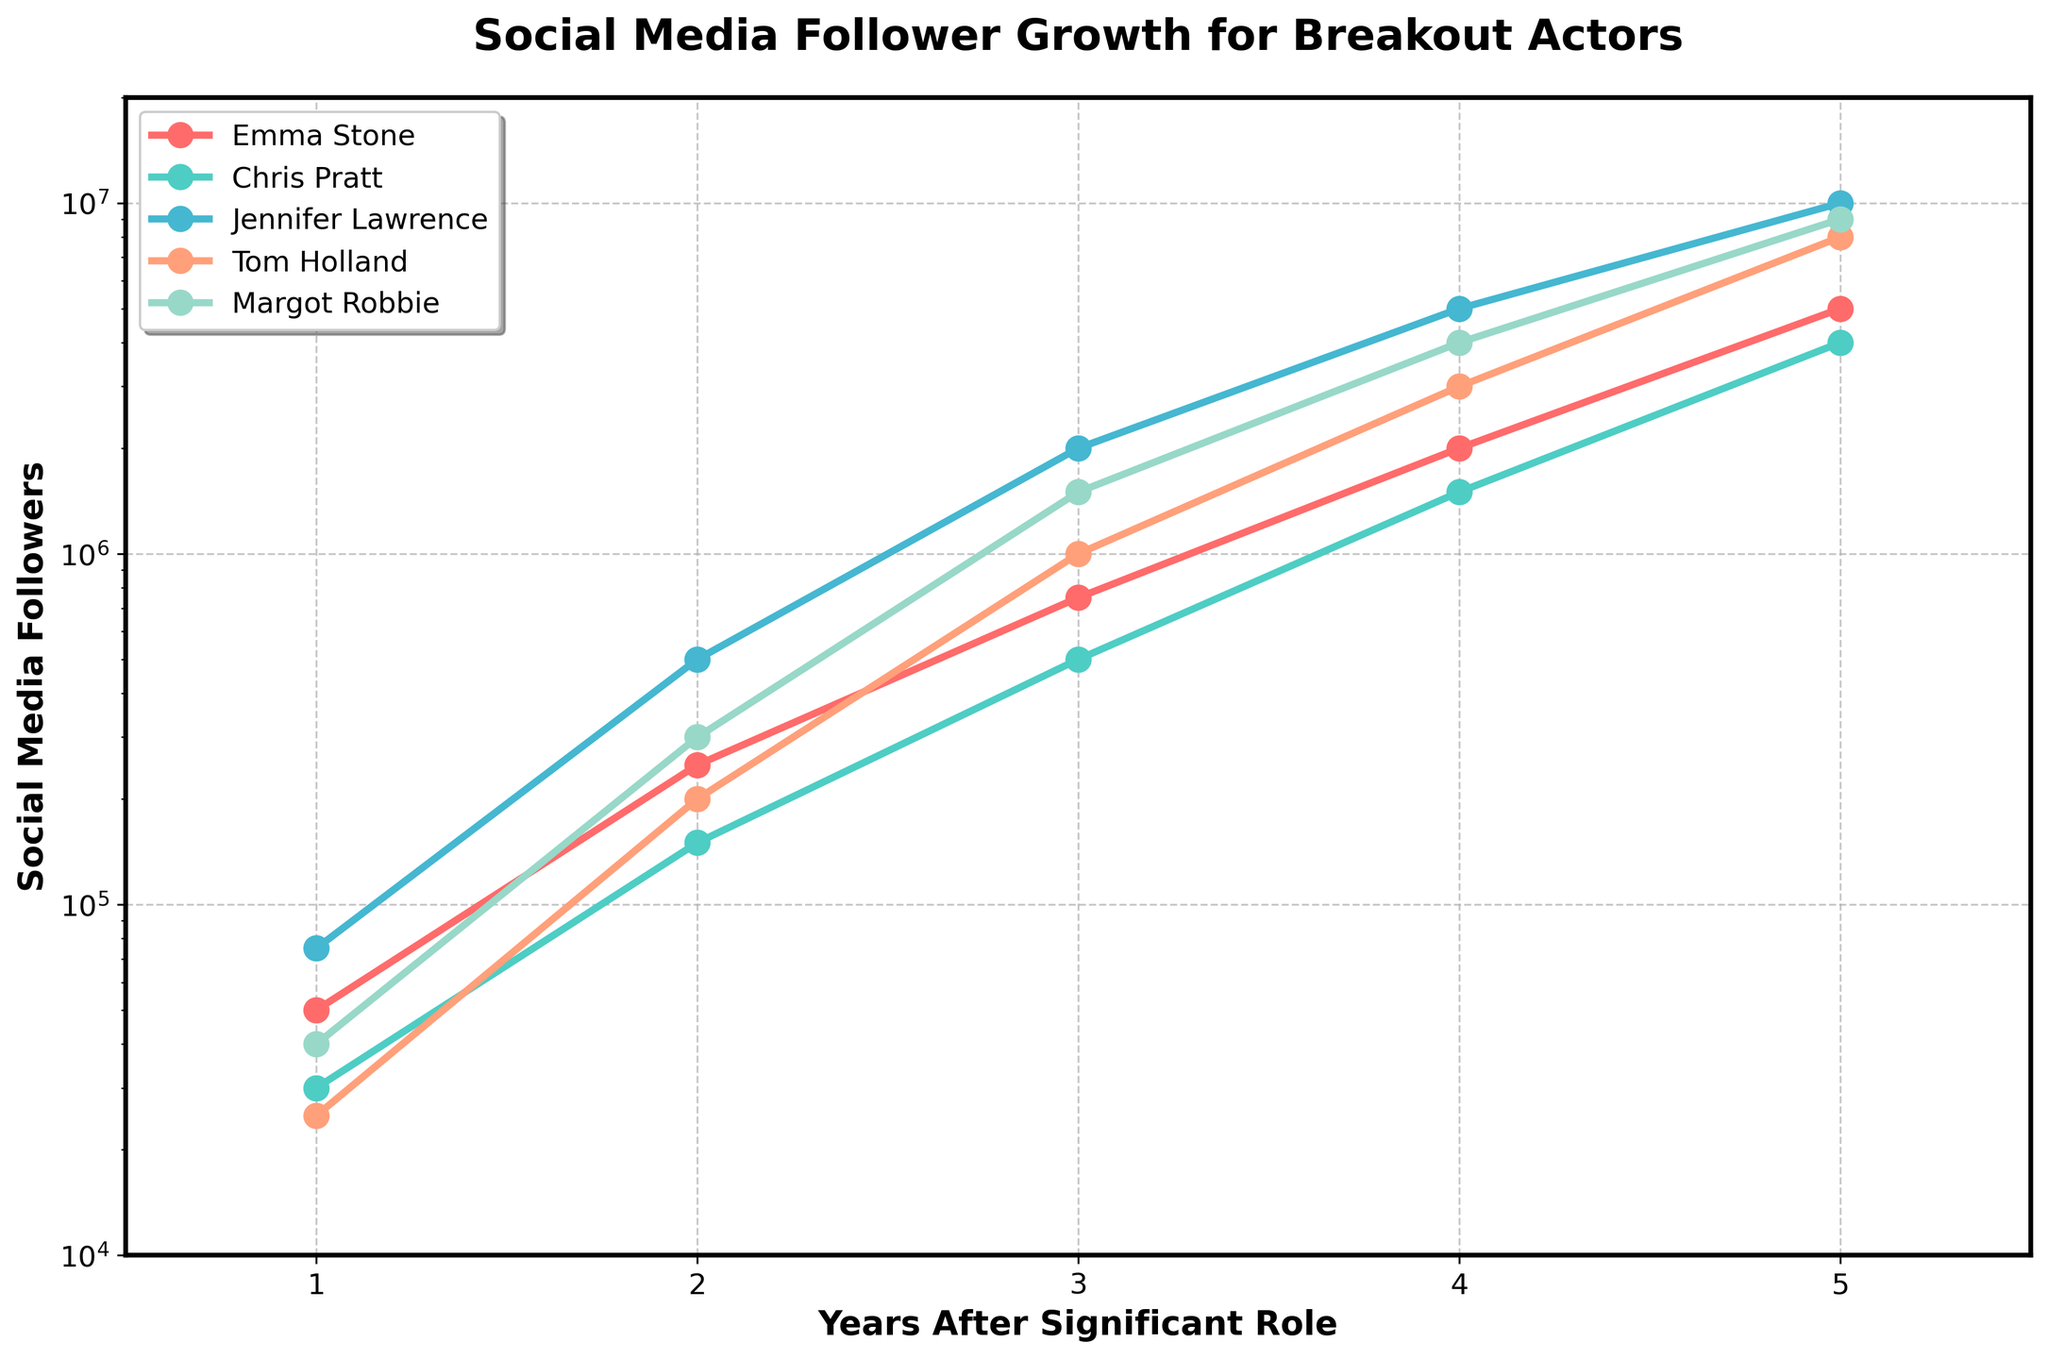What's the total follower count for Margot Robbie in Year 3? In Year 3, Margot Robbie has 1,500,000 followers. The figure shows this directly in the upward trend of her follower count on the line chart.
Answer: 1,500,000 Who had the highest follower growth between Year 2 and Year 3? To determine the highest growth, calculate the difference in followers for each actor between Year 2 and Year 3, and compare:
- Emma Stone: 750,000 - 250,000 = 500,000
- Chris Pratt: 500,000 - 150,000 = 350,000
- Jennifer Lawrence: 2,000,000 - 500,000 = 1,500,000
- Tom Holland: 1,000,000 - 200,000 = 800,000
- Margot Robbie: 1,500,000 - 300,000 = 1,200,000
Jennifer Lawrence shows the highest growth of 1,500,000 followers.
Answer: Jennifer Lawrence What's the ratio of followers between Emma Stone and Chris Pratt in Year 4? In Year 4, Emma Stone has 2,000,000 followers and Chris Pratt has 1,500,000 followers. The ratio is 2,000,000:1,500,000 or simplified, 4:3.
Answer: 4:3 Which actor had the second highest follower count in Year 5? By looking at the Year 5 data:
- Emma Stone: 5,000,000
- Chris Pratt: 4,000,000
- Jennifer Lawrence: 10,000,000
- Tom Holland: 8,000,000
- Margot Robbie: 9,000,000
Tom Holland had the second highest follower count in Year 5 at 8,000,000.
Answer: Tom Holland How many years did it take for Chris Pratt to reach over 1,000,000 followers? By looking at Chris Pratt's line, he reached over 1,000,000 followers in Year 3, transitioning from 150,000 in Year 2 to 500,000 in Year 3.
Answer: 3 years Compare the follower growth trends of Emma Stone and Tom Holland over the 5 years. Emma Stone's and Tom Holland's follower growth trends both show exponential increases, but Tom Holland's growth rate surpassed Emma Stone's starting from Year 3, achieving higher follower counts overall. Specifically, Emma Stone ended at 5,000,000 followers while Tom Holland finished at 8,000,000.
Answer: Tom Holland grew faster During which year did all actors break the 1,000,000 followers mark? By Year 4, all actors surpass the 1,000,000 followers threshold: 
- Emma Stone: 2,000,000
- Chris Pratt: 1,500,000
- Jennifer Lawrence: 5,000,000
- Tom Holland: 3,000,000
- Margot Robbie: 4,000,000
Answer: Year 4 